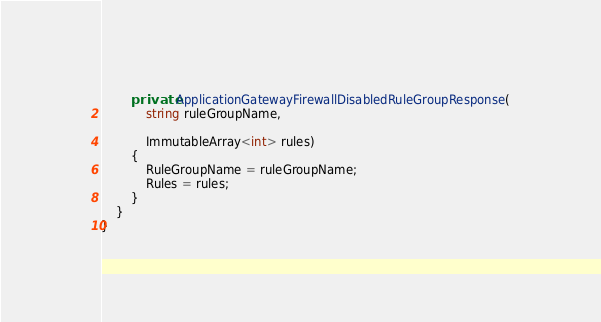<code> <loc_0><loc_0><loc_500><loc_500><_C#_>        private ApplicationGatewayFirewallDisabledRuleGroupResponse(
            string ruleGroupName,

            ImmutableArray<int> rules)
        {
            RuleGroupName = ruleGroupName;
            Rules = rules;
        }
    }
}
</code> 